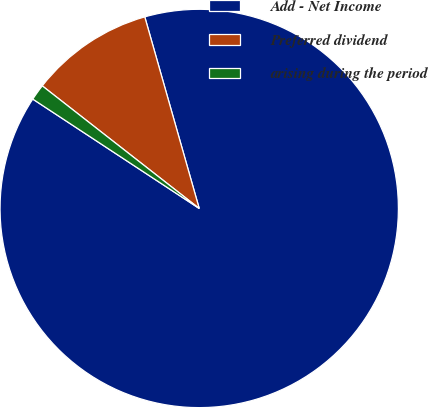<chart> <loc_0><loc_0><loc_500><loc_500><pie_chart><fcel>Add - Net Income<fcel>Preferred dividend<fcel>arising during the period<nl><fcel>88.66%<fcel>10.04%<fcel>1.3%<nl></chart> 